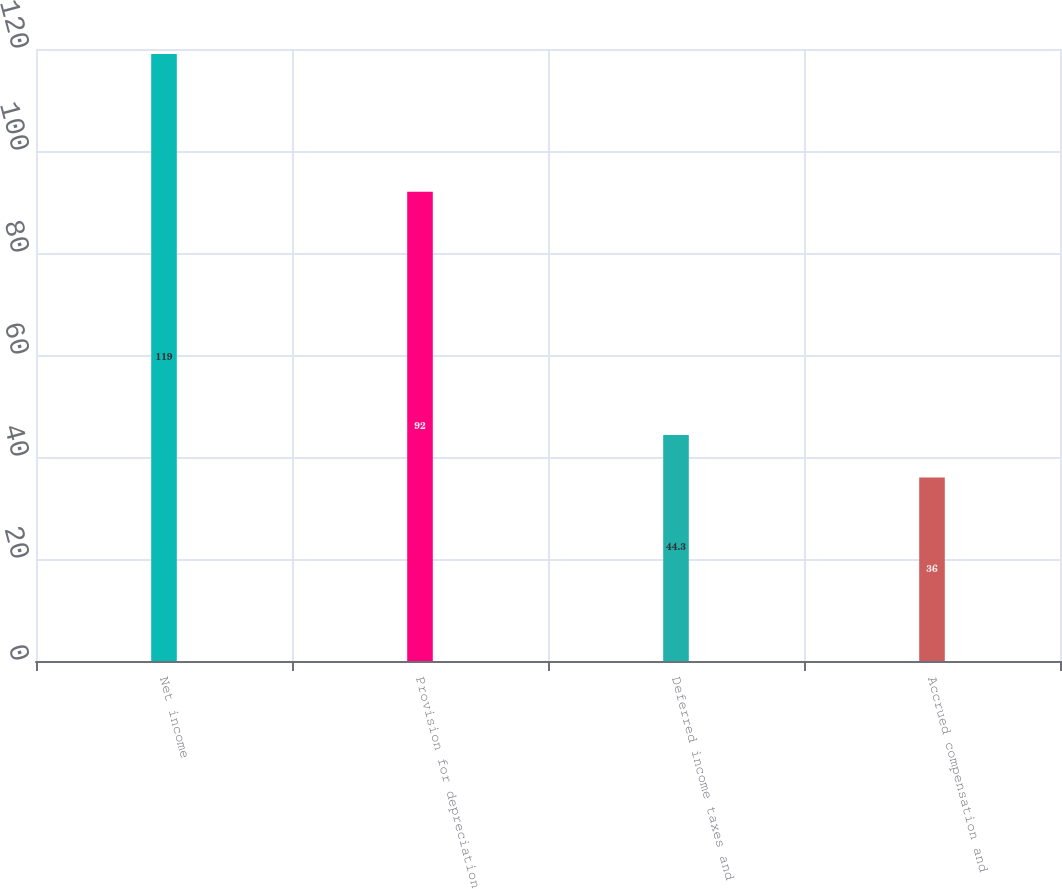<chart> <loc_0><loc_0><loc_500><loc_500><bar_chart><fcel>Net income<fcel>Provision for depreciation<fcel>Deferred income taxes and<fcel>Accrued compensation and<nl><fcel>119<fcel>92<fcel>44.3<fcel>36<nl></chart> 